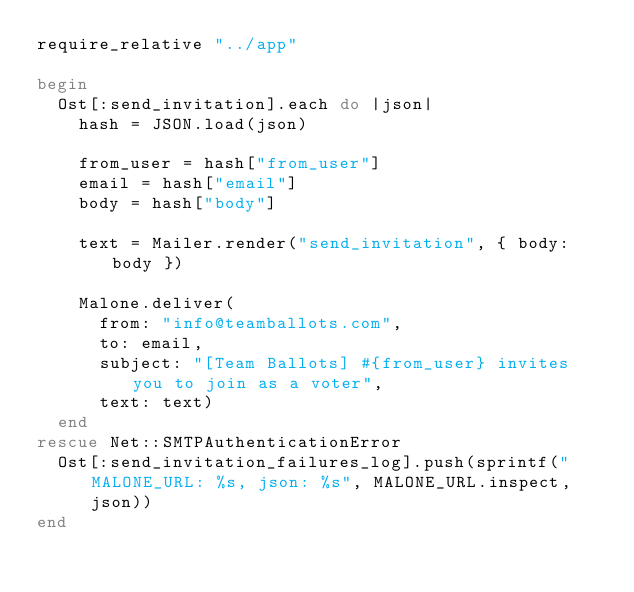<code> <loc_0><loc_0><loc_500><loc_500><_Ruby_>require_relative "../app"

begin
  Ost[:send_invitation].each do |json|
    hash = JSON.load(json)

    from_user = hash["from_user"]
    email = hash["email"]
    body = hash["body"]

    text = Mailer.render("send_invitation", { body: body })

    Malone.deliver(
      from: "info@teamballots.com",
      to: email,
      subject: "[Team Ballots] #{from_user} invites you to join as a voter",
      text: text)
  end
rescue Net::SMTPAuthenticationError
  Ost[:send_invitation_failures_log].push(sprintf("MALONE_URL: %s, json: %s", MALONE_URL.inspect, json))
end
</code> 